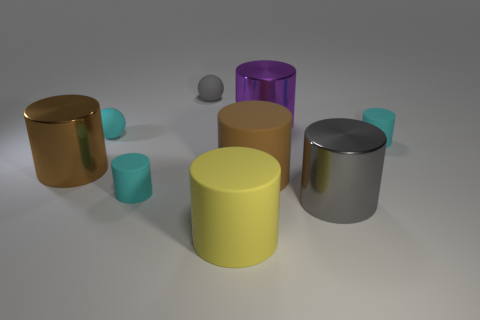There is a tiny ball on the left side of the small gray thing; is its color the same as the tiny matte object that is in front of the brown matte thing?
Provide a short and direct response. Yes. What size is the yellow rubber object in front of the large brown rubber object?
Offer a terse response. Large. There is a gray shiny thing to the left of the small cyan matte object on the right side of the gray object that is behind the big purple cylinder; what size is it?
Your response must be concise. Large. Is the size of the cyan ball the same as the yellow cylinder?
Make the answer very short. No. There is a metal object that is behind the cyan cylinder behind the brown shiny object; what is its size?
Provide a succinct answer. Large. What size is the gray metallic thing?
Provide a succinct answer. Large. The other big matte object that is the same shape as the large yellow matte object is what color?
Keep it short and to the point. Brown. What number of gray cylinders have the same material as the yellow thing?
Your answer should be compact. 0. The rubber cylinder that is the same size as the brown rubber thing is what color?
Keep it short and to the point. Yellow. There is a gray object right of the yellow matte cylinder; does it have the same shape as the tiny cyan rubber object to the right of the big yellow object?
Ensure brevity in your answer.  Yes. 